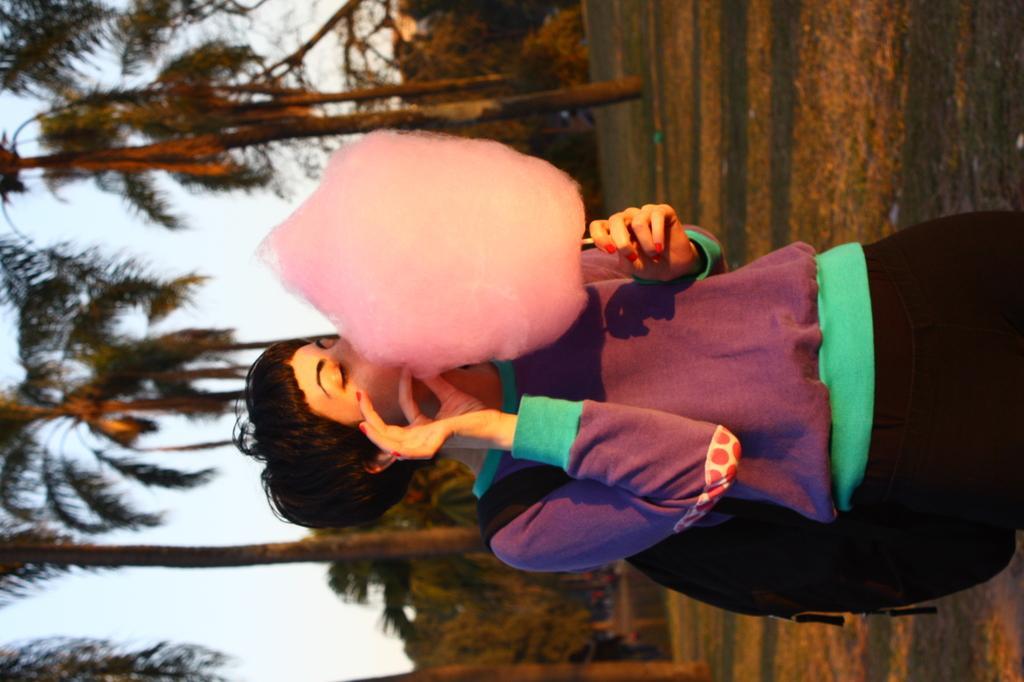Could you give a brief overview of what you see in this image? In this image we can see a lady wearing a bag and she is holding a cotton candy. In the background there are trees and sky. 